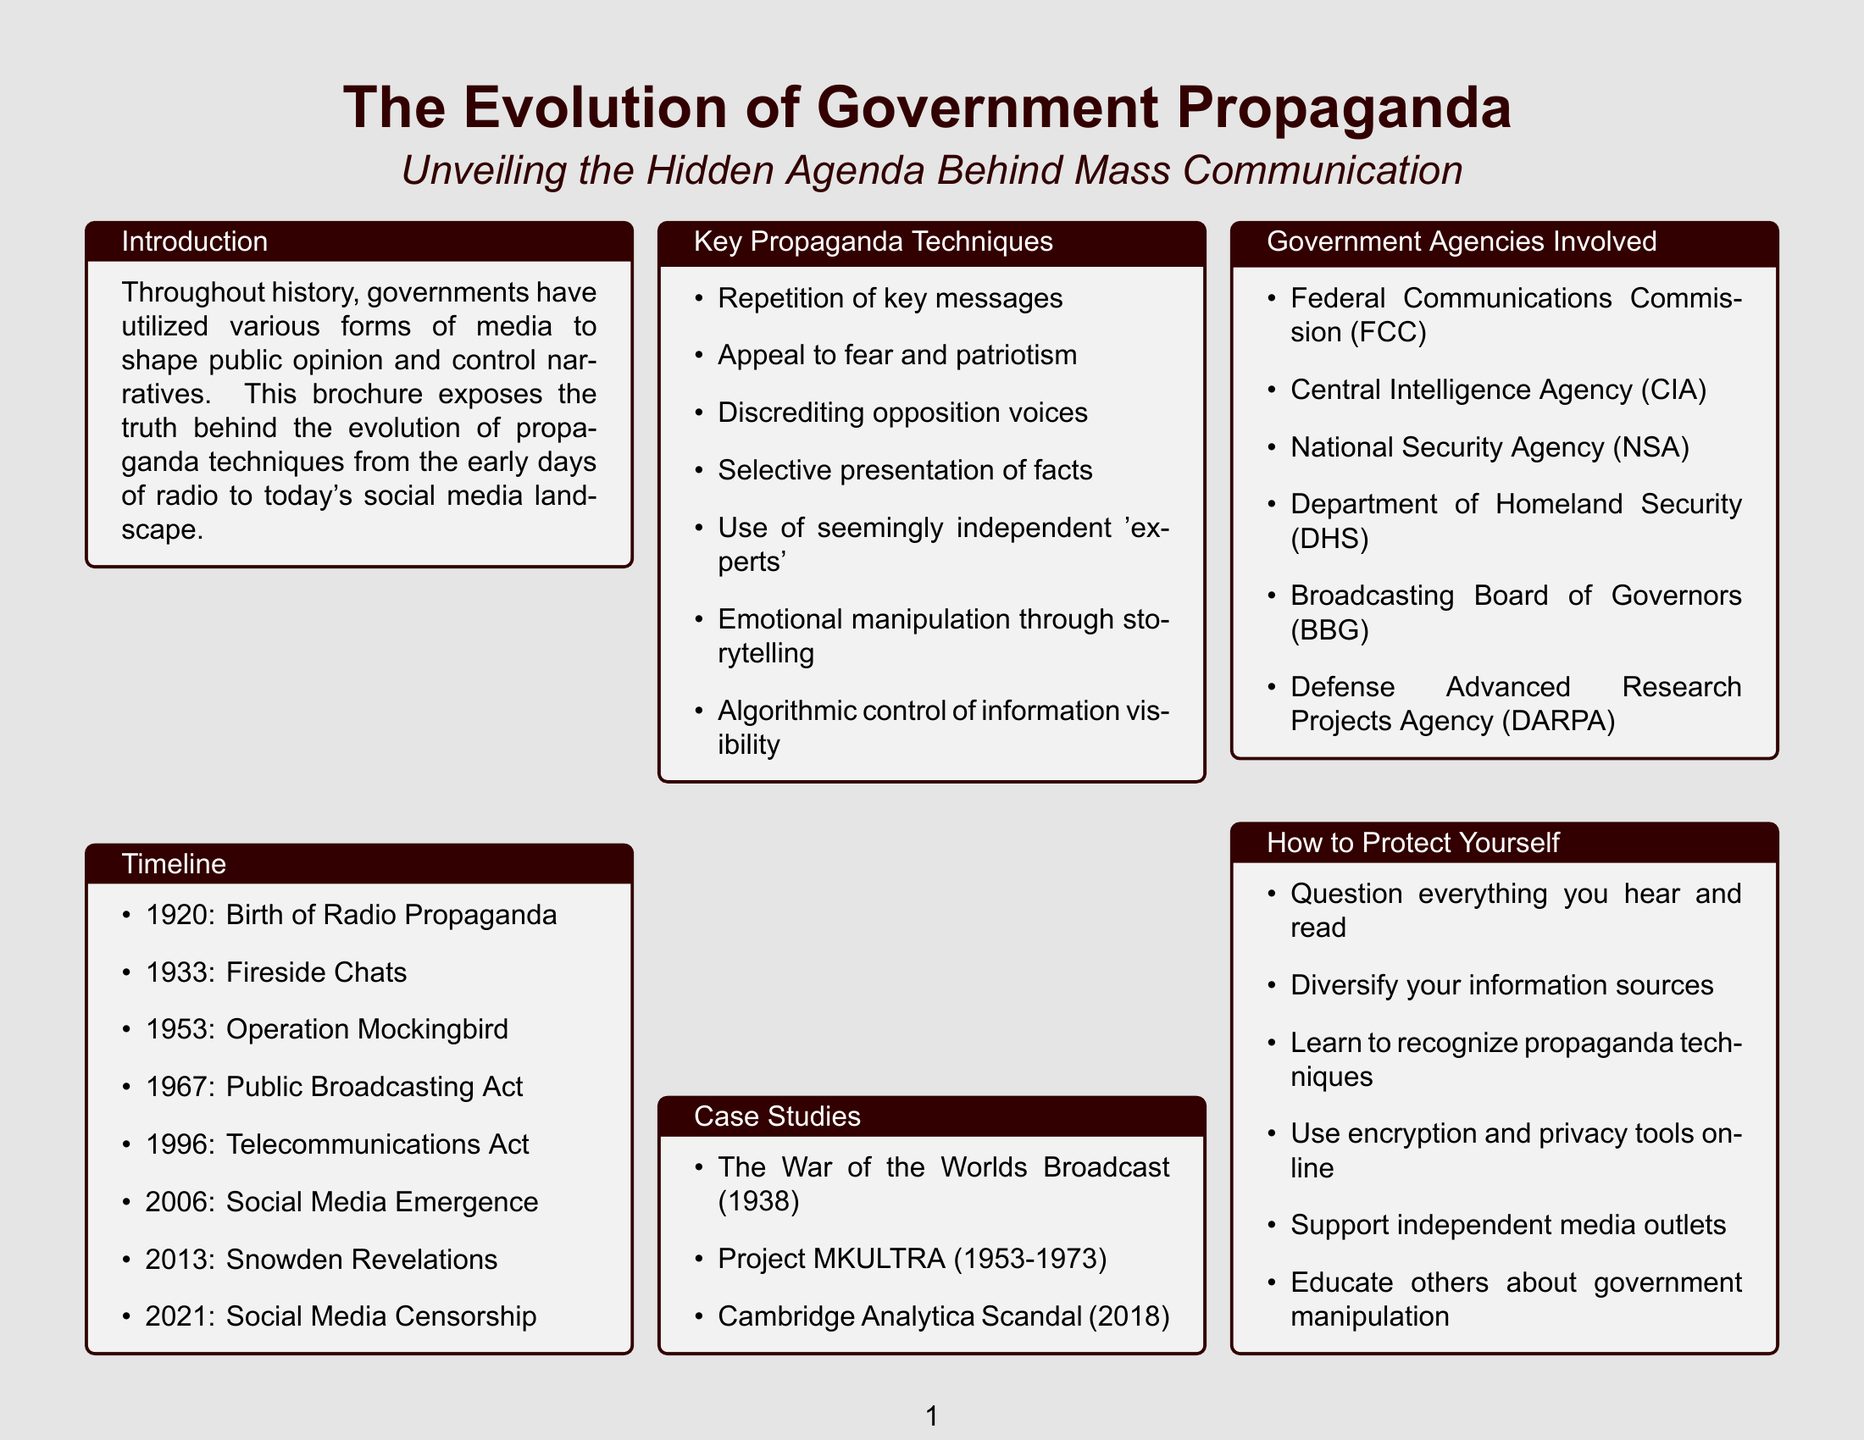What year did the U.S. government establish the Radio Division? The document states that the Radio Division was established in 1920 as a part of the birth of radio propaganda.
Answer: 1920 What propaganda technique involves emotional manipulation? The document lists emotional manipulation through storytelling as one of the key propaganda techniques.
Answer: Emotional manipulation through storytelling What is the name of the radio program used by FDR? The brochure refers to "Fireside Chats," a program utilized by President Franklin D. Roosevelt.
Answer: Fireside Chats Which case study involves a media panic? The brochure mentions "The War of the Worlds Broadcast" as an example of media causing public panic.
Answer: The War of the Worlds Broadcast What year did the Snowden Revelations occur? According to the timeline in the document, the Snowden Revelations took place in 2013.
Answer: 2013 Which agency is known for involvement in propaganda and surveillance? The brochure lists the Central Intelligence Agency (CIA) among the government agencies involved in propaganda manipulation.
Answer: Central Intelligence Agency (CIA) How can individuals protect themselves from propaganda? The document gives multiple suggestions, one of which includes questioning everything heard and read.
Answer: Question everything you hear and read What year marked the emergence of social media? The document states that social media emerged in 2006 when Twitter and Facebook became publicly accessible.
Answer: 2006 